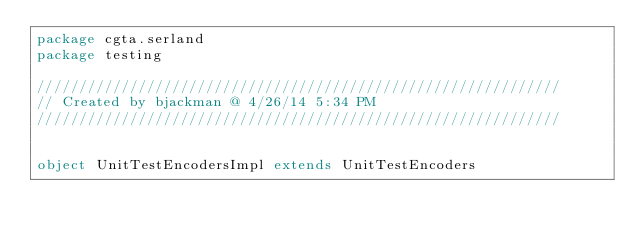Convert code to text. <code><loc_0><loc_0><loc_500><loc_500><_Scala_>package cgta.serland
package testing

//////////////////////////////////////////////////////////////
// Created by bjackman @ 4/26/14 5:34 PM
//////////////////////////////////////////////////////////////


object UnitTestEncodersImpl extends UnitTestEncoders</code> 